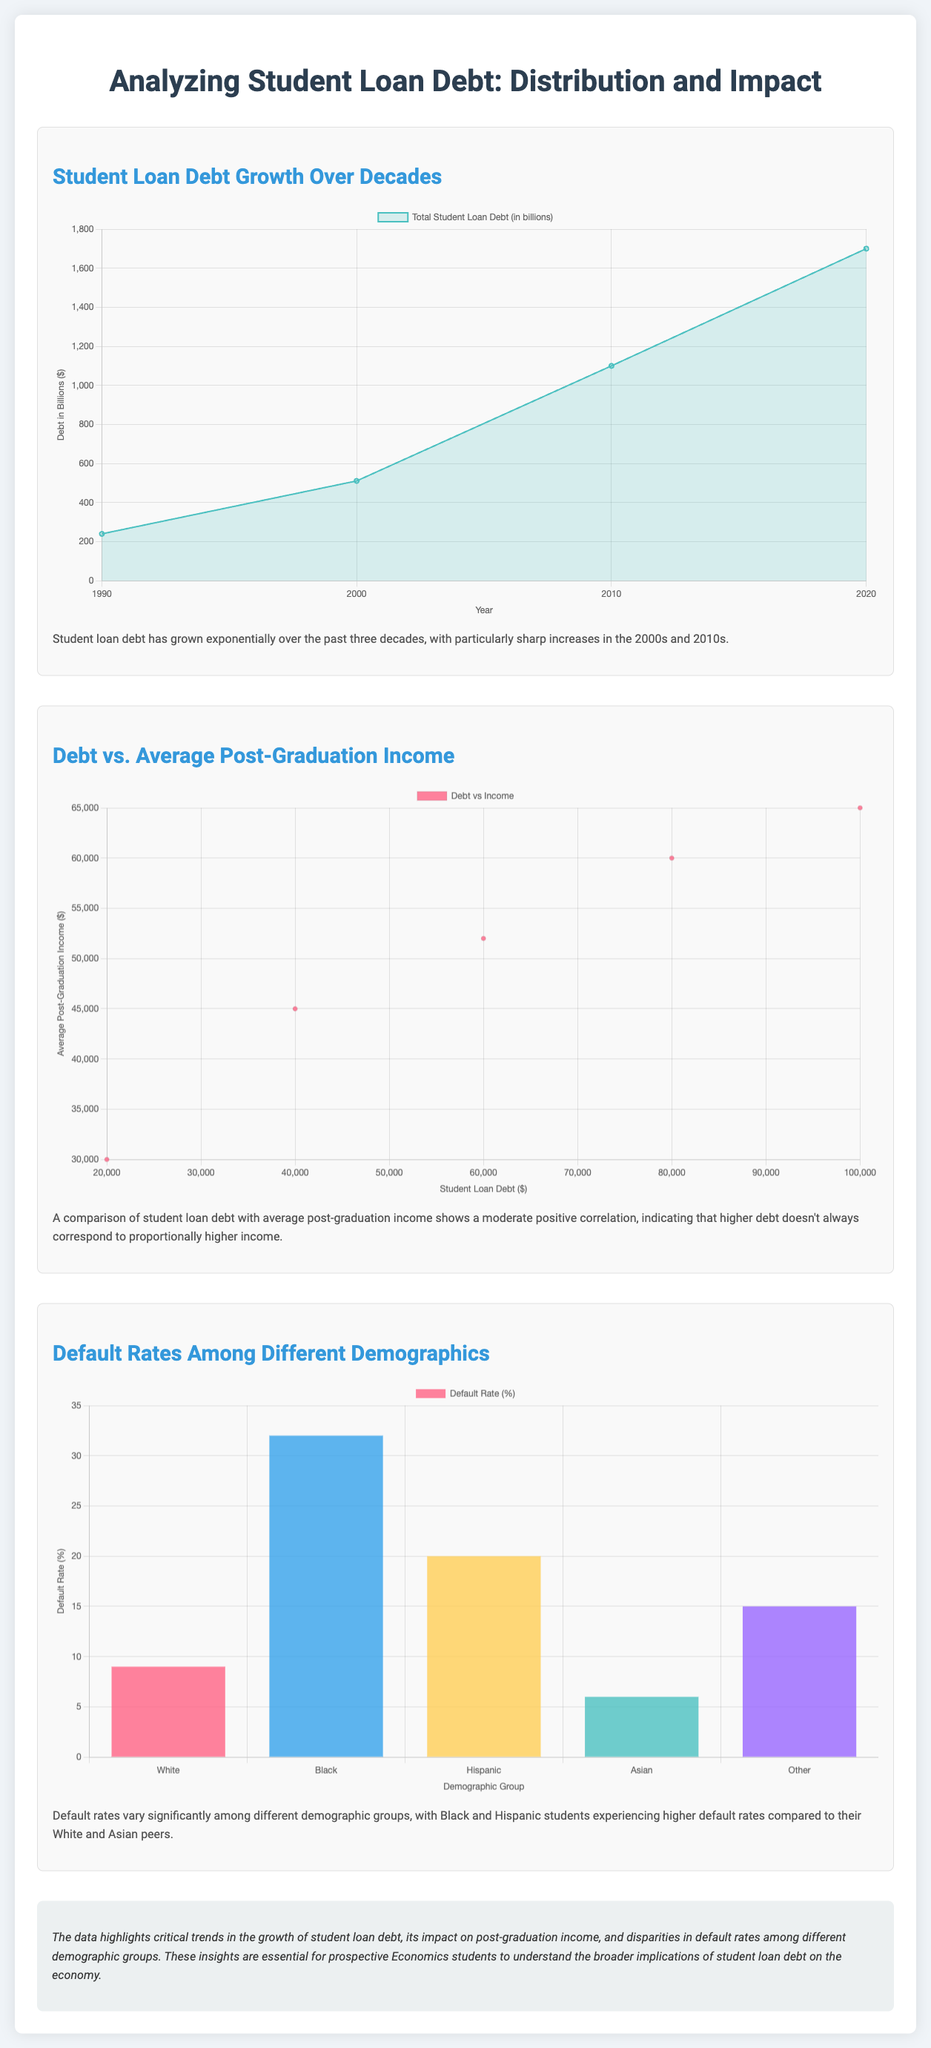What is the total student loan debt in 2020? The total student loan debt in 2020 is represented by the data point at that year in the chart, which is 1700 billion dollars.
Answer: 1700 billion dollars What demographic group has the highest default rate? The default rates chart shows that the demographic group with the highest default rate is Black students, with a rate of 32%.
Answer: Black What is the average post-graduation income for a debt of $60,000? From the debt vs. income scatter plot, the average post-graduation income for a debt of $60,000 is 52,000 dollars.
Answer: 52,000 dollars What percentage of White students default on their loans? According to the default rates chart, 9% of White students default on their loans.
Answer: 9% What decade saw particularly sharp increases in student loan debt? The infographic mentions particularly sharp increases in the 2000s and 2010s as highlighted in the debt growth description.
Answer: 2000s and 2010s What is the relationship between student loan debt and average post-graduation income? The document describes the relationship as a moderate positive correlation, indicating that higher debt doesn't always correspond to proportionally higher income.
Answer: Moderate positive correlation What was the total student loan debt in 1990? The data point for total student loan debt in 1990 is indicated as 240 billion dollars in the area chart.
Answer: 240 billion dollars Which demographic group has the lowest default rate? The default rates chart shows that Asian students have the lowest default rate of 6%.
Answer: Asian 